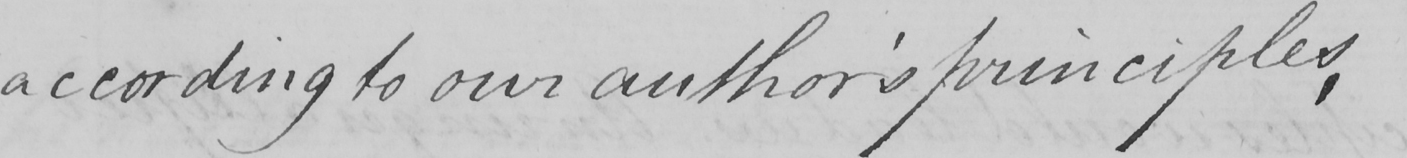Transcribe the text shown in this historical manuscript line. according to our Author ' s principles , 